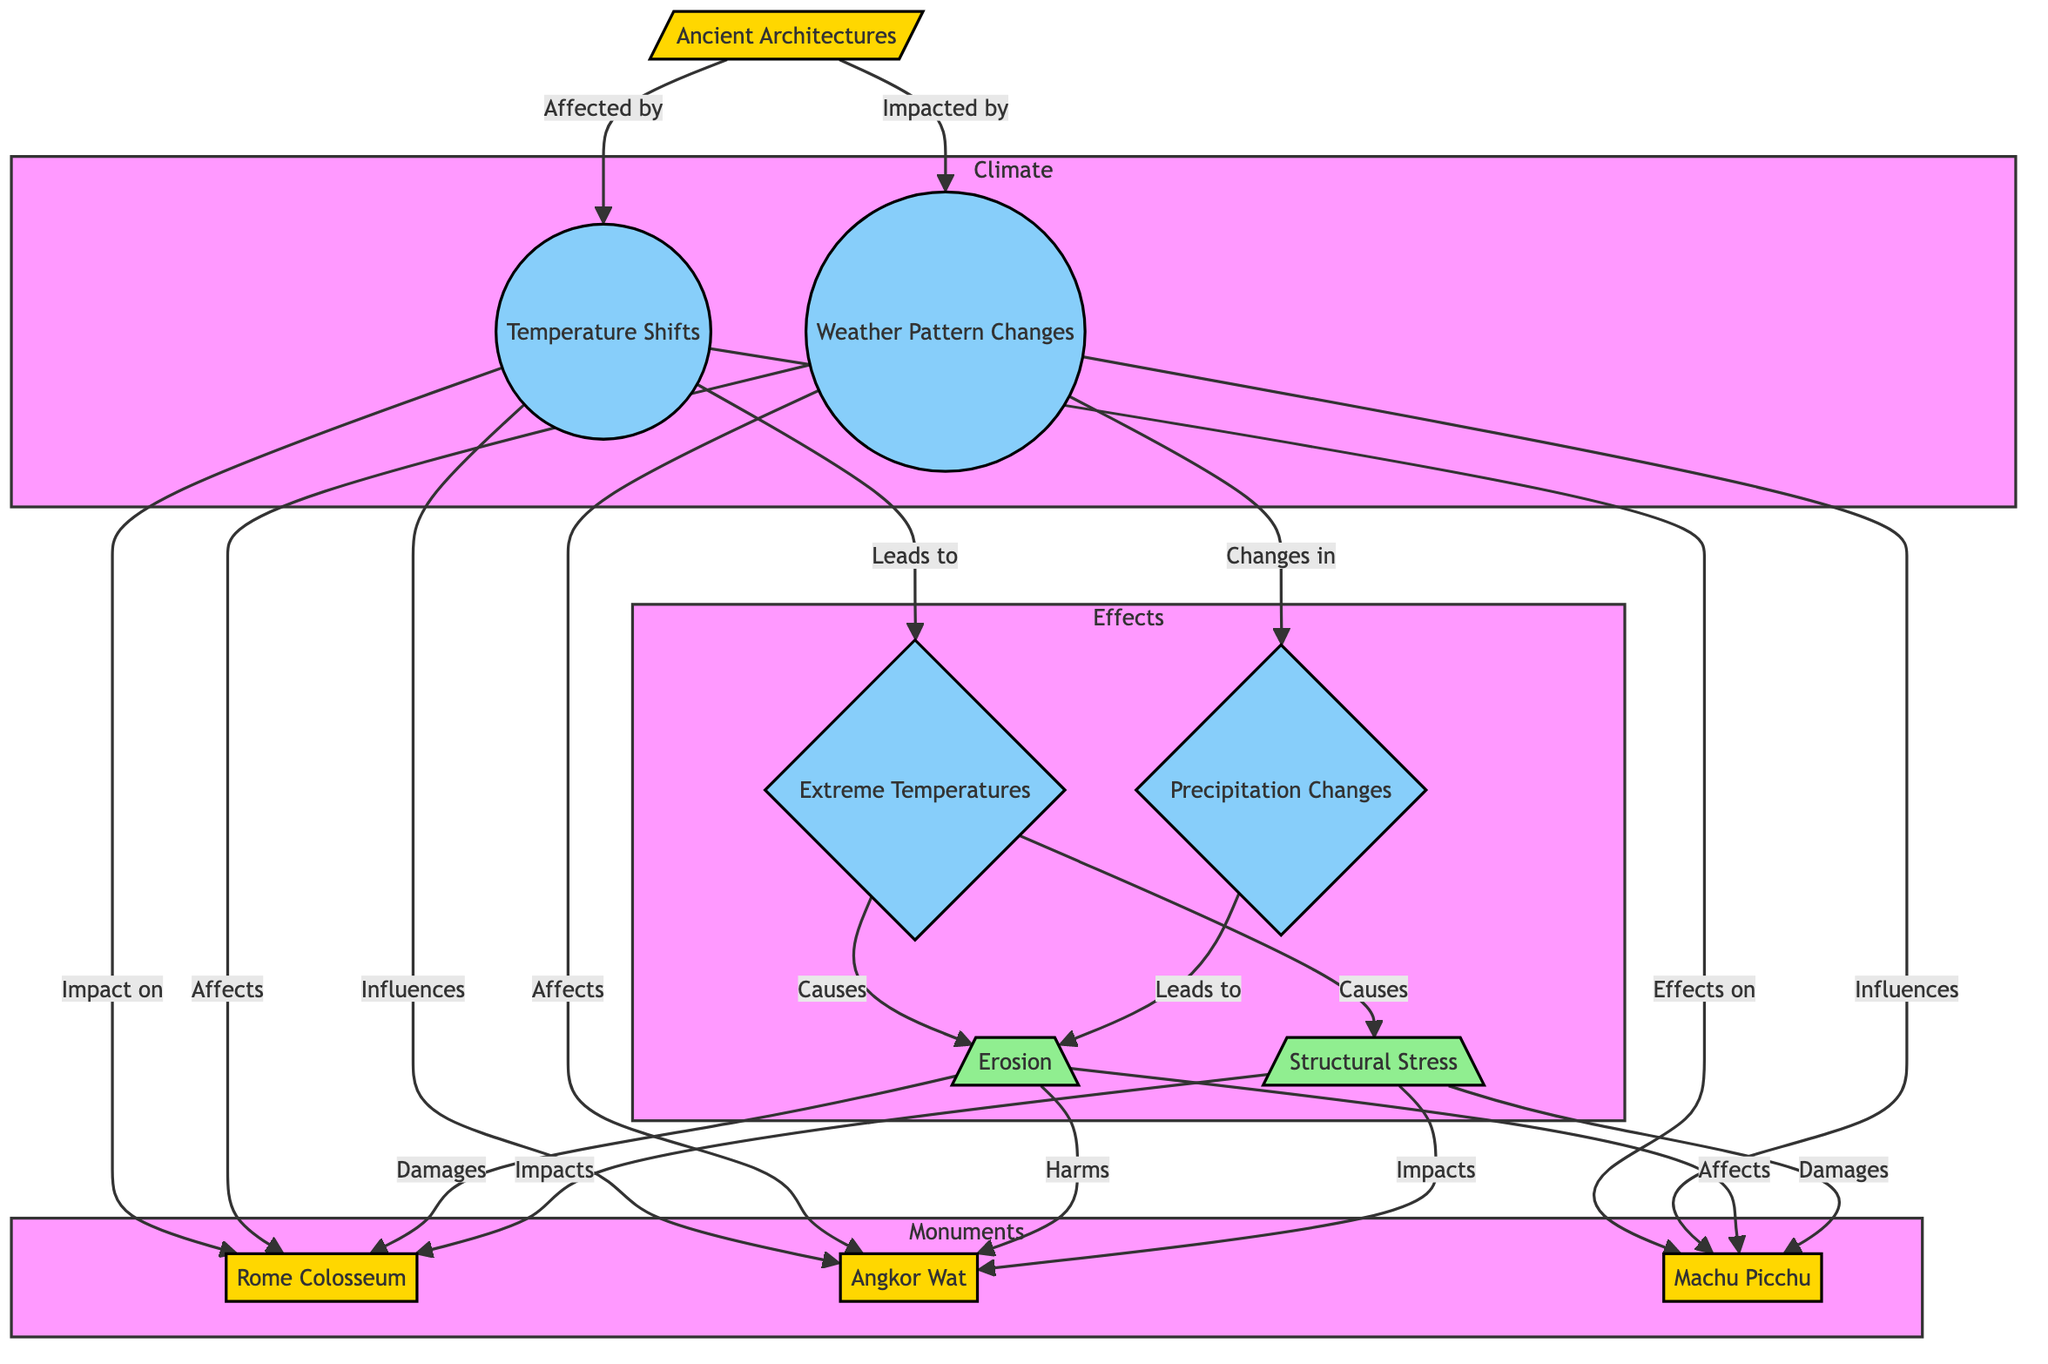What are the three ancient architectures depicted in the diagram? The diagram lists three ancient architectures: the Rome Colosseum, Angkor Wat, and Machu Picchu. They are specifically mentioned under the "Monuments" section of the flowchart.
Answer: Rome Colosseum, Angkor Wat, Machu Picchu What influences do temperature shifts have on ancient architectures? Temperature shifts influence the Rome Colosseum, Angkor Wat, and Machu Picchu as indicated by the arrows connecting temperature shifts to each architectural node.
Answer: Rome Colosseum, Angkor Wat, Machu Picchu What is the relationship between extreme temperatures and erosion? Extreme temperatures cause erosion as shown by the arrow leading from the extreme temperatures node to the erosion node. This indicates a direct effect of extreme temperatures on erosion.
Answer: Causes How many nodes represent ancient architectures in total? There are three nodes in the "Monuments" subgraph representing ancient architectures: Rome Colosseum, Angkor Wat, and Machu Picchu.
Answer: 3 What type of changes do weather patterns lead to according to the diagram? According to the diagram, weather patterns lead to precipitation changes, as depicted by the arrow from the weather patterns node to the precipitation patterns node.
Answer: Precipitation Changes Which ancient architecture is specifically affected by erosion and structural stress? All three ancient architectures—Rome Colosseum, Angkor Wat, and Machu Picchu—are affected by both erosion and structural stress, as indicated by the connections from the erosion node and the structural stress node.
Answer: All three What do both extreme temperatures and precipitation patterns cause? Both extreme temperatures and precipitation patterns lead to erosion. The diagram shows arrows leading from both of these nodes to the erosion node, indicating a direct causal link.
Answer: Erosion Which ancient architecture is labeled as "Harms" in relation to erosion? The diagram indicates that erosion "Harms" Angkor Wat, specifically labeled under the effects of erosion. This demonstrates the detrimental impact of erosion on that particular structure.
Answer: Angkor Wat 